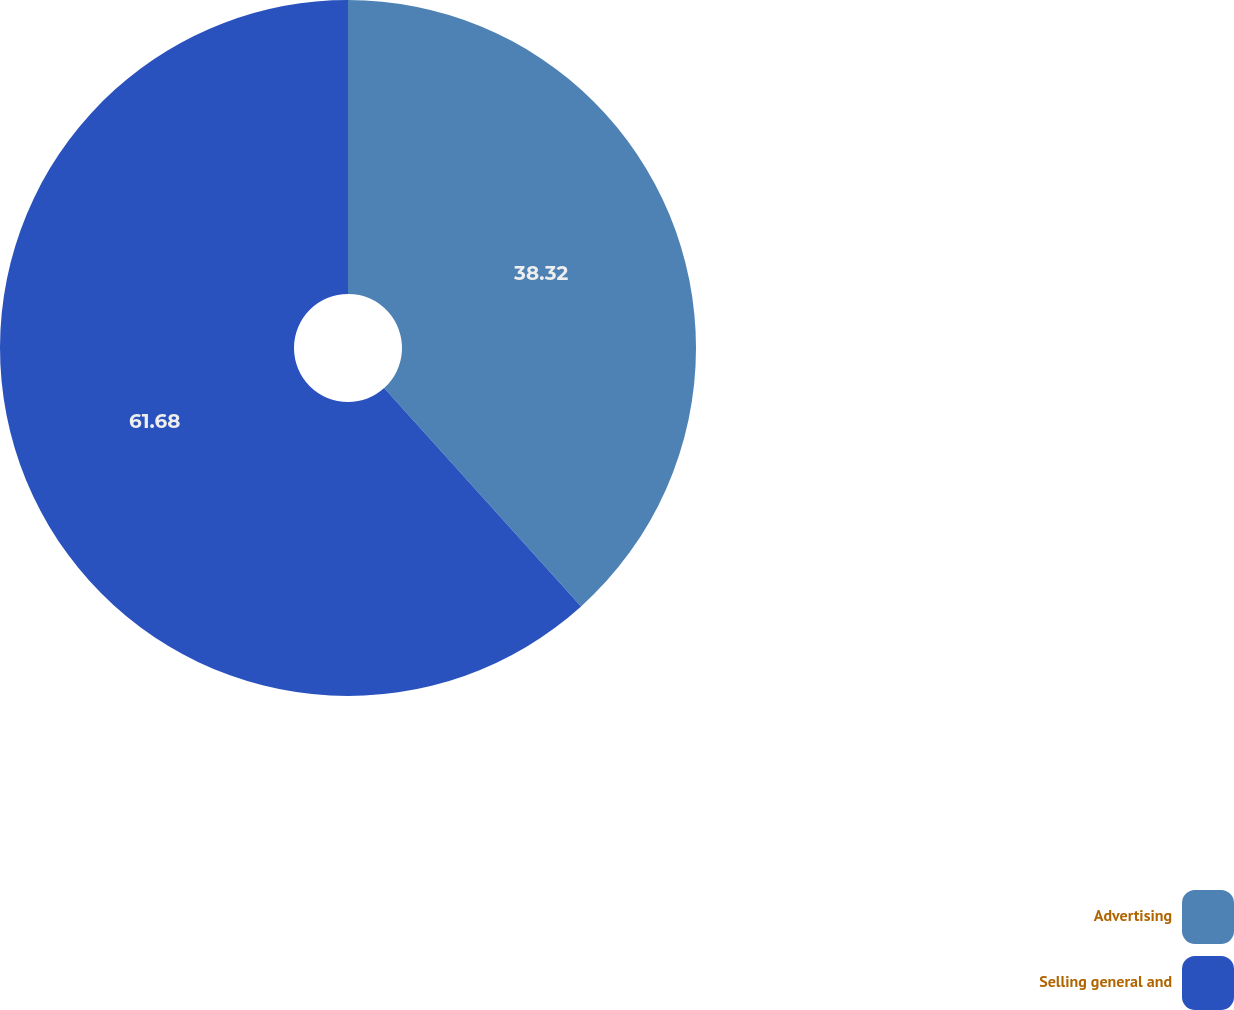Convert chart to OTSL. <chart><loc_0><loc_0><loc_500><loc_500><pie_chart><fcel>Advertising<fcel>Selling general and<nl><fcel>38.32%<fcel>61.68%<nl></chart> 